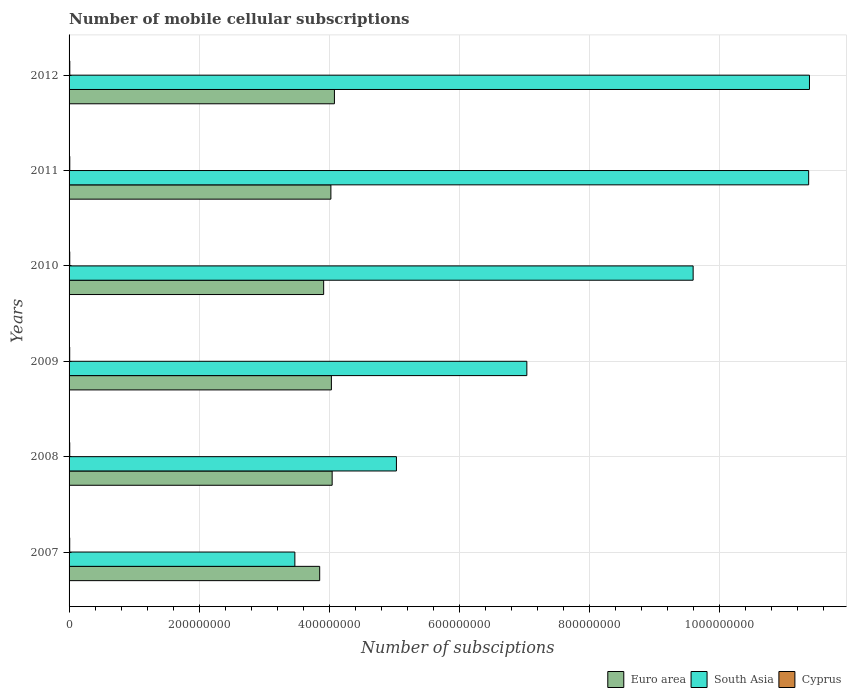How many different coloured bars are there?
Offer a very short reply. 3. Are the number of bars per tick equal to the number of legend labels?
Make the answer very short. Yes. Are the number of bars on each tick of the Y-axis equal?
Your response must be concise. Yes. How many bars are there on the 2nd tick from the bottom?
Your answer should be very brief. 3. In how many cases, is the number of bars for a given year not equal to the number of legend labels?
Offer a very short reply. 0. What is the number of mobile cellular subscriptions in Euro area in 2011?
Provide a succinct answer. 4.03e+08. Across all years, what is the maximum number of mobile cellular subscriptions in Cyprus?
Provide a short and direct response. 1.11e+06. Across all years, what is the minimum number of mobile cellular subscriptions in Euro area?
Ensure brevity in your answer.  3.85e+08. In which year was the number of mobile cellular subscriptions in Euro area maximum?
Make the answer very short. 2012. What is the total number of mobile cellular subscriptions in South Asia in the graph?
Make the answer very short. 4.79e+09. What is the difference between the number of mobile cellular subscriptions in South Asia in 2008 and that in 2010?
Provide a short and direct response. -4.56e+08. What is the difference between the number of mobile cellular subscriptions in South Asia in 2010 and the number of mobile cellular subscriptions in Cyprus in 2009?
Provide a short and direct response. 9.59e+08. What is the average number of mobile cellular subscriptions in South Asia per year?
Offer a terse response. 7.98e+08. In the year 2010, what is the difference between the number of mobile cellular subscriptions in South Asia and number of mobile cellular subscriptions in Euro area?
Provide a succinct answer. 5.68e+08. What is the ratio of the number of mobile cellular subscriptions in Cyprus in 2007 to that in 2008?
Offer a very short reply. 0.97. Is the number of mobile cellular subscriptions in Euro area in 2008 less than that in 2011?
Give a very brief answer. No. Is the difference between the number of mobile cellular subscriptions in South Asia in 2007 and 2010 greater than the difference between the number of mobile cellular subscriptions in Euro area in 2007 and 2010?
Make the answer very short. No. What is the difference between the highest and the second highest number of mobile cellular subscriptions in Euro area?
Ensure brevity in your answer.  3.47e+06. What is the difference between the highest and the lowest number of mobile cellular subscriptions in Euro area?
Keep it short and to the point. 2.27e+07. In how many years, is the number of mobile cellular subscriptions in Euro area greater than the average number of mobile cellular subscriptions in Euro area taken over all years?
Provide a short and direct response. 4. Is the sum of the number of mobile cellular subscriptions in Euro area in 2007 and 2011 greater than the maximum number of mobile cellular subscriptions in Cyprus across all years?
Your response must be concise. Yes. How many bars are there?
Your answer should be very brief. 18. Are the values on the major ticks of X-axis written in scientific E-notation?
Your answer should be compact. No. Does the graph contain any zero values?
Your answer should be very brief. No. Does the graph contain grids?
Your answer should be compact. Yes. How many legend labels are there?
Make the answer very short. 3. How are the legend labels stacked?
Your answer should be very brief. Horizontal. What is the title of the graph?
Provide a succinct answer. Number of mobile cellular subscriptions. What is the label or title of the X-axis?
Ensure brevity in your answer.  Number of subsciptions. What is the label or title of the Y-axis?
Provide a short and direct response. Years. What is the Number of subsciptions in Euro area in 2007?
Make the answer very short. 3.85e+08. What is the Number of subsciptions of South Asia in 2007?
Give a very brief answer. 3.47e+08. What is the Number of subsciptions of Cyprus in 2007?
Ensure brevity in your answer.  9.88e+05. What is the Number of subsciptions of Euro area in 2008?
Your response must be concise. 4.05e+08. What is the Number of subsciptions of South Asia in 2008?
Offer a terse response. 5.03e+08. What is the Number of subsciptions of Cyprus in 2008?
Ensure brevity in your answer.  1.02e+06. What is the Number of subsciptions of Euro area in 2009?
Provide a succinct answer. 4.03e+08. What is the Number of subsciptions in South Asia in 2009?
Keep it short and to the point. 7.04e+08. What is the Number of subsciptions of Cyprus in 2009?
Offer a very short reply. 9.78e+05. What is the Number of subsciptions in Euro area in 2010?
Your answer should be very brief. 3.92e+08. What is the Number of subsciptions of South Asia in 2010?
Offer a very short reply. 9.60e+08. What is the Number of subsciptions in Cyprus in 2010?
Your response must be concise. 1.03e+06. What is the Number of subsciptions in Euro area in 2011?
Make the answer very short. 4.03e+08. What is the Number of subsciptions in South Asia in 2011?
Your response must be concise. 1.14e+09. What is the Number of subsciptions in Cyprus in 2011?
Ensure brevity in your answer.  1.09e+06. What is the Number of subsciptions in Euro area in 2012?
Your answer should be very brief. 4.08e+08. What is the Number of subsciptions of South Asia in 2012?
Provide a succinct answer. 1.14e+09. What is the Number of subsciptions in Cyprus in 2012?
Your response must be concise. 1.11e+06. Across all years, what is the maximum Number of subsciptions of Euro area?
Give a very brief answer. 4.08e+08. Across all years, what is the maximum Number of subsciptions in South Asia?
Provide a succinct answer. 1.14e+09. Across all years, what is the maximum Number of subsciptions in Cyprus?
Offer a very short reply. 1.11e+06. Across all years, what is the minimum Number of subsciptions in Euro area?
Ensure brevity in your answer.  3.85e+08. Across all years, what is the minimum Number of subsciptions of South Asia?
Your answer should be very brief. 3.47e+08. Across all years, what is the minimum Number of subsciptions in Cyprus?
Offer a very short reply. 9.78e+05. What is the total Number of subsciptions of Euro area in the graph?
Your answer should be very brief. 2.40e+09. What is the total Number of subsciptions in South Asia in the graph?
Give a very brief answer. 4.79e+09. What is the total Number of subsciptions of Cyprus in the graph?
Ensure brevity in your answer.  6.22e+06. What is the difference between the Number of subsciptions of Euro area in 2007 and that in 2008?
Offer a terse response. -1.92e+07. What is the difference between the Number of subsciptions in South Asia in 2007 and that in 2008?
Provide a succinct answer. -1.56e+08. What is the difference between the Number of subsciptions in Cyprus in 2007 and that in 2008?
Offer a terse response. -2.84e+04. What is the difference between the Number of subsciptions of Euro area in 2007 and that in 2009?
Make the answer very short. -1.80e+07. What is the difference between the Number of subsciptions in South Asia in 2007 and that in 2009?
Your response must be concise. -3.57e+08. What is the difference between the Number of subsciptions in Cyprus in 2007 and that in 2009?
Make the answer very short. 1.08e+04. What is the difference between the Number of subsciptions of Euro area in 2007 and that in 2010?
Keep it short and to the point. -6.10e+06. What is the difference between the Number of subsciptions in South Asia in 2007 and that in 2010?
Provide a short and direct response. -6.13e+08. What is the difference between the Number of subsciptions in Cyprus in 2007 and that in 2010?
Keep it short and to the point. -4.58e+04. What is the difference between the Number of subsciptions of Euro area in 2007 and that in 2011?
Offer a very short reply. -1.72e+07. What is the difference between the Number of subsciptions of South Asia in 2007 and that in 2011?
Provide a short and direct response. -7.90e+08. What is the difference between the Number of subsciptions in Cyprus in 2007 and that in 2011?
Offer a terse response. -1.03e+05. What is the difference between the Number of subsciptions in Euro area in 2007 and that in 2012?
Give a very brief answer. -2.27e+07. What is the difference between the Number of subsciptions in South Asia in 2007 and that in 2012?
Make the answer very short. -7.91e+08. What is the difference between the Number of subsciptions in Cyprus in 2007 and that in 2012?
Offer a very short reply. -1.23e+05. What is the difference between the Number of subsciptions of Euro area in 2008 and that in 2009?
Provide a short and direct response. 1.19e+06. What is the difference between the Number of subsciptions in South Asia in 2008 and that in 2009?
Provide a succinct answer. -2.01e+08. What is the difference between the Number of subsciptions in Cyprus in 2008 and that in 2009?
Offer a very short reply. 3.92e+04. What is the difference between the Number of subsciptions in Euro area in 2008 and that in 2010?
Your answer should be compact. 1.31e+07. What is the difference between the Number of subsciptions in South Asia in 2008 and that in 2010?
Provide a succinct answer. -4.56e+08. What is the difference between the Number of subsciptions of Cyprus in 2008 and that in 2010?
Make the answer very short. -1.73e+04. What is the difference between the Number of subsciptions in Euro area in 2008 and that in 2011?
Your answer should be compact. 1.96e+06. What is the difference between the Number of subsciptions of South Asia in 2008 and that in 2011?
Give a very brief answer. -6.34e+08. What is the difference between the Number of subsciptions of Cyprus in 2008 and that in 2011?
Your response must be concise. -7.42e+04. What is the difference between the Number of subsciptions in Euro area in 2008 and that in 2012?
Ensure brevity in your answer.  -3.47e+06. What is the difference between the Number of subsciptions in South Asia in 2008 and that in 2012?
Make the answer very short. -6.35e+08. What is the difference between the Number of subsciptions of Cyprus in 2008 and that in 2012?
Your response must be concise. -9.42e+04. What is the difference between the Number of subsciptions in Euro area in 2009 and that in 2010?
Provide a succinct answer. 1.19e+07. What is the difference between the Number of subsciptions of South Asia in 2009 and that in 2010?
Provide a succinct answer. -2.56e+08. What is the difference between the Number of subsciptions of Cyprus in 2009 and that in 2010?
Ensure brevity in your answer.  -5.66e+04. What is the difference between the Number of subsciptions of Euro area in 2009 and that in 2011?
Offer a terse response. 7.66e+05. What is the difference between the Number of subsciptions of South Asia in 2009 and that in 2011?
Your response must be concise. -4.33e+08. What is the difference between the Number of subsciptions in Cyprus in 2009 and that in 2011?
Provide a short and direct response. -1.13e+05. What is the difference between the Number of subsciptions of Euro area in 2009 and that in 2012?
Make the answer very short. -4.66e+06. What is the difference between the Number of subsciptions of South Asia in 2009 and that in 2012?
Provide a short and direct response. -4.35e+08. What is the difference between the Number of subsciptions in Cyprus in 2009 and that in 2012?
Ensure brevity in your answer.  -1.33e+05. What is the difference between the Number of subsciptions in Euro area in 2010 and that in 2011?
Your response must be concise. -1.11e+07. What is the difference between the Number of subsciptions of South Asia in 2010 and that in 2011?
Offer a terse response. -1.78e+08. What is the difference between the Number of subsciptions in Cyprus in 2010 and that in 2011?
Your response must be concise. -5.69e+04. What is the difference between the Number of subsciptions in Euro area in 2010 and that in 2012?
Provide a succinct answer. -1.66e+07. What is the difference between the Number of subsciptions in South Asia in 2010 and that in 2012?
Your answer should be very brief. -1.79e+08. What is the difference between the Number of subsciptions in Cyprus in 2010 and that in 2012?
Give a very brief answer. -7.69e+04. What is the difference between the Number of subsciptions in Euro area in 2011 and that in 2012?
Give a very brief answer. -5.43e+06. What is the difference between the Number of subsciptions in South Asia in 2011 and that in 2012?
Your answer should be compact. -1.26e+06. What is the difference between the Number of subsciptions of Cyprus in 2011 and that in 2012?
Offer a very short reply. -2.00e+04. What is the difference between the Number of subsciptions of Euro area in 2007 and the Number of subsciptions of South Asia in 2008?
Offer a terse response. -1.18e+08. What is the difference between the Number of subsciptions in Euro area in 2007 and the Number of subsciptions in Cyprus in 2008?
Make the answer very short. 3.84e+08. What is the difference between the Number of subsciptions of South Asia in 2007 and the Number of subsciptions of Cyprus in 2008?
Make the answer very short. 3.46e+08. What is the difference between the Number of subsciptions of Euro area in 2007 and the Number of subsciptions of South Asia in 2009?
Ensure brevity in your answer.  -3.19e+08. What is the difference between the Number of subsciptions in Euro area in 2007 and the Number of subsciptions in Cyprus in 2009?
Make the answer very short. 3.84e+08. What is the difference between the Number of subsciptions in South Asia in 2007 and the Number of subsciptions in Cyprus in 2009?
Offer a very short reply. 3.46e+08. What is the difference between the Number of subsciptions of Euro area in 2007 and the Number of subsciptions of South Asia in 2010?
Make the answer very short. -5.74e+08. What is the difference between the Number of subsciptions in Euro area in 2007 and the Number of subsciptions in Cyprus in 2010?
Keep it short and to the point. 3.84e+08. What is the difference between the Number of subsciptions of South Asia in 2007 and the Number of subsciptions of Cyprus in 2010?
Your answer should be very brief. 3.46e+08. What is the difference between the Number of subsciptions in Euro area in 2007 and the Number of subsciptions in South Asia in 2011?
Offer a very short reply. -7.52e+08. What is the difference between the Number of subsciptions of Euro area in 2007 and the Number of subsciptions of Cyprus in 2011?
Keep it short and to the point. 3.84e+08. What is the difference between the Number of subsciptions in South Asia in 2007 and the Number of subsciptions in Cyprus in 2011?
Provide a succinct answer. 3.46e+08. What is the difference between the Number of subsciptions in Euro area in 2007 and the Number of subsciptions in South Asia in 2012?
Provide a short and direct response. -7.53e+08. What is the difference between the Number of subsciptions in Euro area in 2007 and the Number of subsciptions in Cyprus in 2012?
Offer a terse response. 3.84e+08. What is the difference between the Number of subsciptions in South Asia in 2007 and the Number of subsciptions in Cyprus in 2012?
Make the answer very short. 3.46e+08. What is the difference between the Number of subsciptions in Euro area in 2008 and the Number of subsciptions in South Asia in 2009?
Keep it short and to the point. -2.99e+08. What is the difference between the Number of subsciptions in Euro area in 2008 and the Number of subsciptions in Cyprus in 2009?
Give a very brief answer. 4.04e+08. What is the difference between the Number of subsciptions of South Asia in 2008 and the Number of subsciptions of Cyprus in 2009?
Offer a terse response. 5.02e+08. What is the difference between the Number of subsciptions of Euro area in 2008 and the Number of subsciptions of South Asia in 2010?
Keep it short and to the point. -5.55e+08. What is the difference between the Number of subsciptions in Euro area in 2008 and the Number of subsciptions in Cyprus in 2010?
Give a very brief answer. 4.04e+08. What is the difference between the Number of subsciptions of South Asia in 2008 and the Number of subsciptions of Cyprus in 2010?
Give a very brief answer. 5.02e+08. What is the difference between the Number of subsciptions of Euro area in 2008 and the Number of subsciptions of South Asia in 2011?
Give a very brief answer. -7.33e+08. What is the difference between the Number of subsciptions in Euro area in 2008 and the Number of subsciptions in Cyprus in 2011?
Keep it short and to the point. 4.04e+08. What is the difference between the Number of subsciptions in South Asia in 2008 and the Number of subsciptions in Cyprus in 2011?
Provide a succinct answer. 5.02e+08. What is the difference between the Number of subsciptions of Euro area in 2008 and the Number of subsciptions of South Asia in 2012?
Your response must be concise. -7.34e+08. What is the difference between the Number of subsciptions of Euro area in 2008 and the Number of subsciptions of Cyprus in 2012?
Your answer should be compact. 4.03e+08. What is the difference between the Number of subsciptions of South Asia in 2008 and the Number of subsciptions of Cyprus in 2012?
Keep it short and to the point. 5.02e+08. What is the difference between the Number of subsciptions of Euro area in 2009 and the Number of subsciptions of South Asia in 2010?
Offer a terse response. -5.56e+08. What is the difference between the Number of subsciptions of Euro area in 2009 and the Number of subsciptions of Cyprus in 2010?
Your response must be concise. 4.02e+08. What is the difference between the Number of subsciptions of South Asia in 2009 and the Number of subsciptions of Cyprus in 2010?
Ensure brevity in your answer.  7.03e+08. What is the difference between the Number of subsciptions of Euro area in 2009 and the Number of subsciptions of South Asia in 2011?
Give a very brief answer. -7.34e+08. What is the difference between the Number of subsciptions in Euro area in 2009 and the Number of subsciptions in Cyprus in 2011?
Your answer should be very brief. 4.02e+08. What is the difference between the Number of subsciptions of South Asia in 2009 and the Number of subsciptions of Cyprus in 2011?
Provide a succinct answer. 7.03e+08. What is the difference between the Number of subsciptions of Euro area in 2009 and the Number of subsciptions of South Asia in 2012?
Your answer should be very brief. -7.35e+08. What is the difference between the Number of subsciptions of Euro area in 2009 and the Number of subsciptions of Cyprus in 2012?
Provide a succinct answer. 4.02e+08. What is the difference between the Number of subsciptions in South Asia in 2009 and the Number of subsciptions in Cyprus in 2012?
Provide a short and direct response. 7.03e+08. What is the difference between the Number of subsciptions of Euro area in 2010 and the Number of subsciptions of South Asia in 2011?
Your response must be concise. -7.46e+08. What is the difference between the Number of subsciptions of Euro area in 2010 and the Number of subsciptions of Cyprus in 2011?
Ensure brevity in your answer.  3.90e+08. What is the difference between the Number of subsciptions in South Asia in 2010 and the Number of subsciptions in Cyprus in 2011?
Give a very brief answer. 9.59e+08. What is the difference between the Number of subsciptions in Euro area in 2010 and the Number of subsciptions in South Asia in 2012?
Offer a very short reply. -7.47e+08. What is the difference between the Number of subsciptions of Euro area in 2010 and the Number of subsciptions of Cyprus in 2012?
Ensure brevity in your answer.  3.90e+08. What is the difference between the Number of subsciptions of South Asia in 2010 and the Number of subsciptions of Cyprus in 2012?
Offer a terse response. 9.59e+08. What is the difference between the Number of subsciptions in Euro area in 2011 and the Number of subsciptions in South Asia in 2012?
Provide a succinct answer. -7.36e+08. What is the difference between the Number of subsciptions of Euro area in 2011 and the Number of subsciptions of Cyprus in 2012?
Give a very brief answer. 4.02e+08. What is the difference between the Number of subsciptions in South Asia in 2011 and the Number of subsciptions in Cyprus in 2012?
Make the answer very short. 1.14e+09. What is the average Number of subsciptions in Euro area per year?
Provide a succinct answer. 3.99e+08. What is the average Number of subsciptions in South Asia per year?
Your response must be concise. 7.98e+08. What is the average Number of subsciptions in Cyprus per year?
Your response must be concise. 1.04e+06. In the year 2007, what is the difference between the Number of subsciptions in Euro area and Number of subsciptions in South Asia?
Keep it short and to the point. 3.82e+07. In the year 2007, what is the difference between the Number of subsciptions of Euro area and Number of subsciptions of Cyprus?
Provide a succinct answer. 3.84e+08. In the year 2007, what is the difference between the Number of subsciptions in South Asia and Number of subsciptions in Cyprus?
Offer a terse response. 3.46e+08. In the year 2008, what is the difference between the Number of subsciptions of Euro area and Number of subsciptions of South Asia?
Make the answer very short. -9.88e+07. In the year 2008, what is the difference between the Number of subsciptions in Euro area and Number of subsciptions in Cyprus?
Your answer should be very brief. 4.04e+08. In the year 2008, what is the difference between the Number of subsciptions in South Asia and Number of subsciptions in Cyprus?
Make the answer very short. 5.02e+08. In the year 2009, what is the difference between the Number of subsciptions of Euro area and Number of subsciptions of South Asia?
Keep it short and to the point. -3.01e+08. In the year 2009, what is the difference between the Number of subsciptions in Euro area and Number of subsciptions in Cyprus?
Offer a very short reply. 4.02e+08. In the year 2009, what is the difference between the Number of subsciptions of South Asia and Number of subsciptions of Cyprus?
Offer a terse response. 7.03e+08. In the year 2010, what is the difference between the Number of subsciptions of Euro area and Number of subsciptions of South Asia?
Your answer should be compact. -5.68e+08. In the year 2010, what is the difference between the Number of subsciptions in Euro area and Number of subsciptions in Cyprus?
Give a very brief answer. 3.90e+08. In the year 2010, what is the difference between the Number of subsciptions in South Asia and Number of subsciptions in Cyprus?
Your answer should be compact. 9.59e+08. In the year 2011, what is the difference between the Number of subsciptions of Euro area and Number of subsciptions of South Asia?
Provide a short and direct response. -7.35e+08. In the year 2011, what is the difference between the Number of subsciptions of Euro area and Number of subsciptions of Cyprus?
Keep it short and to the point. 4.02e+08. In the year 2011, what is the difference between the Number of subsciptions of South Asia and Number of subsciptions of Cyprus?
Keep it short and to the point. 1.14e+09. In the year 2012, what is the difference between the Number of subsciptions in Euro area and Number of subsciptions in South Asia?
Make the answer very short. -7.31e+08. In the year 2012, what is the difference between the Number of subsciptions of Euro area and Number of subsciptions of Cyprus?
Offer a terse response. 4.07e+08. In the year 2012, what is the difference between the Number of subsciptions in South Asia and Number of subsciptions in Cyprus?
Provide a short and direct response. 1.14e+09. What is the ratio of the Number of subsciptions of Euro area in 2007 to that in 2008?
Your response must be concise. 0.95. What is the ratio of the Number of subsciptions of South Asia in 2007 to that in 2008?
Give a very brief answer. 0.69. What is the ratio of the Number of subsciptions of Euro area in 2007 to that in 2009?
Ensure brevity in your answer.  0.96. What is the ratio of the Number of subsciptions in South Asia in 2007 to that in 2009?
Make the answer very short. 0.49. What is the ratio of the Number of subsciptions in Cyprus in 2007 to that in 2009?
Make the answer very short. 1.01. What is the ratio of the Number of subsciptions in Euro area in 2007 to that in 2010?
Keep it short and to the point. 0.98. What is the ratio of the Number of subsciptions in South Asia in 2007 to that in 2010?
Make the answer very short. 0.36. What is the ratio of the Number of subsciptions of Cyprus in 2007 to that in 2010?
Offer a very short reply. 0.96. What is the ratio of the Number of subsciptions of Euro area in 2007 to that in 2011?
Offer a very short reply. 0.96. What is the ratio of the Number of subsciptions in South Asia in 2007 to that in 2011?
Provide a short and direct response. 0.31. What is the ratio of the Number of subsciptions of Cyprus in 2007 to that in 2011?
Ensure brevity in your answer.  0.91. What is the ratio of the Number of subsciptions of Euro area in 2007 to that in 2012?
Your response must be concise. 0.94. What is the ratio of the Number of subsciptions in South Asia in 2007 to that in 2012?
Provide a succinct answer. 0.3. What is the ratio of the Number of subsciptions of Cyprus in 2007 to that in 2012?
Offer a very short reply. 0.89. What is the ratio of the Number of subsciptions in Euro area in 2008 to that in 2009?
Ensure brevity in your answer.  1. What is the ratio of the Number of subsciptions in South Asia in 2008 to that in 2009?
Keep it short and to the point. 0.72. What is the ratio of the Number of subsciptions of Cyprus in 2008 to that in 2009?
Your response must be concise. 1.04. What is the ratio of the Number of subsciptions of Euro area in 2008 to that in 2010?
Ensure brevity in your answer.  1.03. What is the ratio of the Number of subsciptions in South Asia in 2008 to that in 2010?
Your response must be concise. 0.52. What is the ratio of the Number of subsciptions in Cyprus in 2008 to that in 2010?
Keep it short and to the point. 0.98. What is the ratio of the Number of subsciptions in South Asia in 2008 to that in 2011?
Provide a short and direct response. 0.44. What is the ratio of the Number of subsciptions in Cyprus in 2008 to that in 2011?
Provide a short and direct response. 0.93. What is the ratio of the Number of subsciptions of South Asia in 2008 to that in 2012?
Provide a succinct answer. 0.44. What is the ratio of the Number of subsciptions of Cyprus in 2008 to that in 2012?
Your answer should be compact. 0.92. What is the ratio of the Number of subsciptions in Euro area in 2009 to that in 2010?
Give a very brief answer. 1.03. What is the ratio of the Number of subsciptions of South Asia in 2009 to that in 2010?
Offer a terse response. 0.73. What is the ratio of the Number of subsciptions of Cyprus in 2009 to that in 2010?
Ensure brevity in your answer.  0.95. What is the ratio of the Number of subsciptions of South Asia in 2009 to that in 2011?
Your answer should be very brief. 0.62. What is the ratio of the Number of subsciptions in Cyprus in 2009 to that in 2011?
Offer a terse response. 0.9. What is the ratio of the Number of subsciptions in Euro area in 2009 to that in 2012?
Your response must be concise. 0.99. What is the ratio of the Number of subsciptions in South Asia in 2009 to that in 2012?
Give a very brief answer. 0.62. What is the ratio of the Number of subsciptions of Cyprus in 2009 to that in 2012?
Your answer should be very brief. 0.88. What is the ratio of the Number of subsciptions in Euro area in 2010 to that in 2011?
Offer a very short reply. 0.97. What is the ratio of the Number of subsciptions of South Asia in 2010 to that in 2011?
Provide a succinct answer. 0.84. What is the ratio of the Number of subsciptions of Cyprus in 2010 to that in 2011?
Offer a very short reply. 0.95. What is the ratio of the Number of subsciptions in Euro area in 2010 to that in 2012?
Make the answer very short. 0.96. What is the ratio of the Number of subsciptions in South Asia in 2010 to that in 2012?
Your answer should be compact. 0.84. What is the ratio of the Number of subsciptions of Cyprus in 2010 to that in 2012?
Provide a succinct answer. 0.93. What is the ratio of the Number of subsciptions in Euro area in 2011 to that in 2012?
Your response must be concise. 0.99. What is the ratio of the Number of subsciptions in Cyprus in 2011 to that in 2012?
Your answer should be compact. 0.98. What is the difference between the highest and the second highest Number of subsciptions in Euro area?
Your answer should be very brief. 3.47e+06. What is the difference between the highest and the second highest Number of subsciptions in South Asia?
Make the answer very short. 1.26e+06. What is the difference between the highest and the second highest Number of subsciptions of Cyprus?
Ensure brevity in your answer.  2.00e+04. What is the difference between the highest and the lowest Number of subsciptions of Euro area?
Offer a very short reply. 2.27e+07. What is the difference between the highest and the lowest Number of subsciptions of South Asia?
Keep it short and to the point. 7.91e+08. What is the difference between the highest and the lowest Number of subsciptions of Cyprus?
Provide a short and direct response. 1.33e+05. 